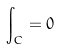Convert formula to latex. <formula><loc_0><loc_0><loc_500><loc_500>\int _ { C } = 0</formula> 